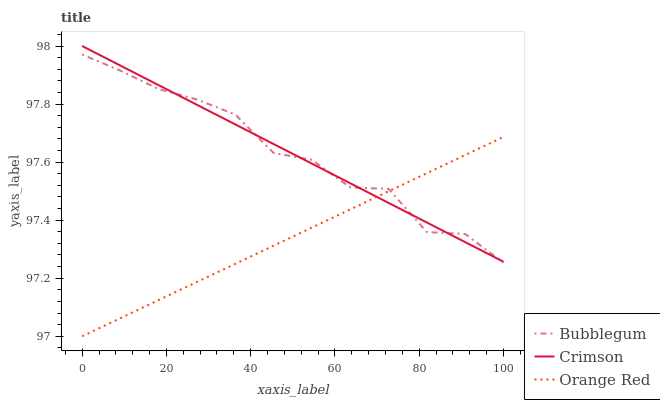Does Orange Red have the minimum area under the curve?
Answer yes or no. Yes. Does Bubblegum have the maximum area under the curve?
Answer yes or no. Yes. Does Bubblegum have the minimum area under the curve?
Answer yes or no. No. Does Orange Red have the maximum area under the curve?
Answer yes or no. No. Is Crimson the smoothest?
Answer yes or no. Yes. Is Bubblegum the roughest?
Answer yes or no. Yes. Is Orange Red the smoothest?
Answer yes or no. No. Is Orange Red the roughest?
Answer yes or no. No. Does Orange Red have the lowest value?
Answer yes or no. Yes. Does Bubblegum have the lowest value?
Answer yes or no. No. Does Crimson have the highest value?
Answer yes or no. Yes. Does Bubblegum have the highest value?
Answer yes or no. No. Does Bubblegum intersect Crimson?
Answer yes or no. Yes. Is Bubblegum less than Crimson?
Answer yes or no. No. Is Bubblegum greater than Crimson?
Answer yes or no. No. 